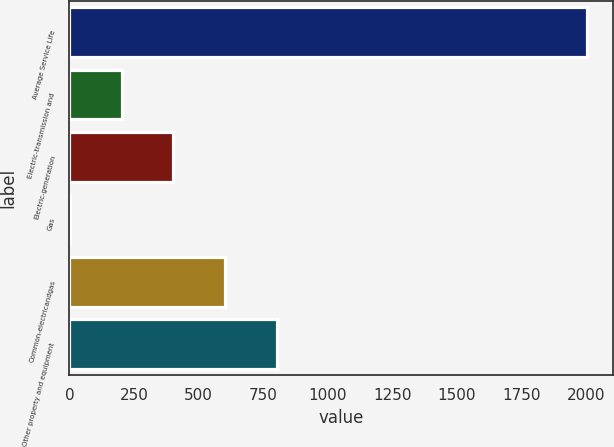Convert chart to OTSL. <chart><loc_0><loc_0><loc_500><loc_500><bar_chart><fcel>Average Service Life<fcel>Electric-transmission and<fcel>Electric-generation<fcel>Gas<fcel>Common-electricandgas<fcel>Other property and equipment<nl><fcel>2004<fcel>202.67<fcel>402.82<fcel>2.52<fcel>602.97<fcel>803.12<nl></chart> 